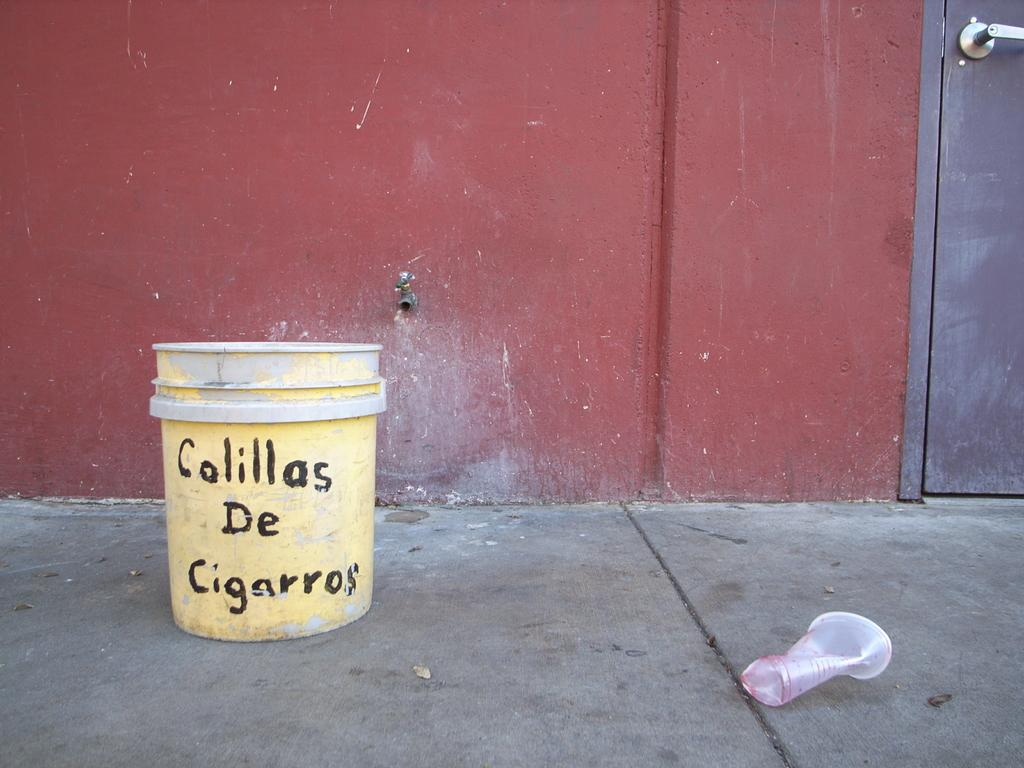What object can be seen on the ground in the foreground of the image? There is a crushed plastic glass on the ground in the foreground. What is located near the crushed plastic glass in the foreground? There is a bucket with text in the foreground. What architectural feature can be seen in the background of the image? There is a door in the background. What color is the wall visible in the background? There is a red wall in the background. What type of lock is visible on the door in the image? There is no lock visible on the door in the image. What letters can be seen on the rail near the door? There is no rail or letters present near the door in the image. 